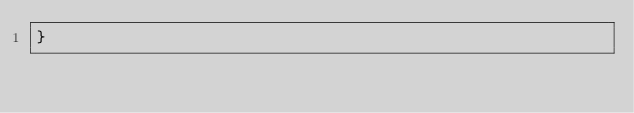<code> <loc_0><loc_0><loc_500><loc_500><_TypeScript_>}
</code> 